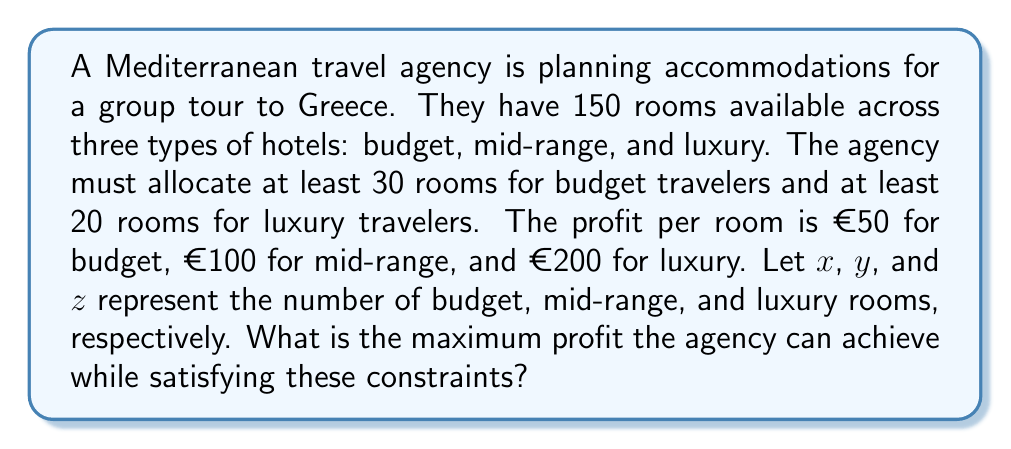Help me with this question. Let's approach this step-by-step:

1) First, we need to set up our system of inequalities based on the given constraints:

   $x + y + z \leq 150$ (total rooms available)
   $x \geq 30$ (minimum budget rooms)
   $z \geq 20$ (minimum luxury rooms)
   $x, y, z \geq 0$ (non-negativity constraint)

2) Our objective function (profit) is:

   $P = 50x + 100y + 200z$

3) To maximize profit, we should allocate as many rooms as possible to luxury, then mid-range, and finally budget (as luxury has the highest profit per room).

4) We start by assigning the minimum required luxury rooms:
   $z = 20$

5) Next, we allocate the remaining rooms to mid-range:
   $y = 150 - 20 - 30 = 100$

6) Finally, we assign the minimum required budget rooms:
   $x = 30$

7) Let's verify our solution satisfies all constraints:
   $30 + 100 + 20 = 150$ (total rooms constraint satisfied)
   $x = 30 \geq 30$ (budget room constraint satisfied)
   $z = 20 \geq 20$ (luxury room constraint satisfied)

8) Now we can calculate the maximum profit:

   $P = 50(30) + 100(100) + 200(20)$
   $P = 1500 + 10000 + 4000$
   $P = 15500$

Therefore, the maximum profit the agency can achieve is €15,500.
Answer: €15,500 